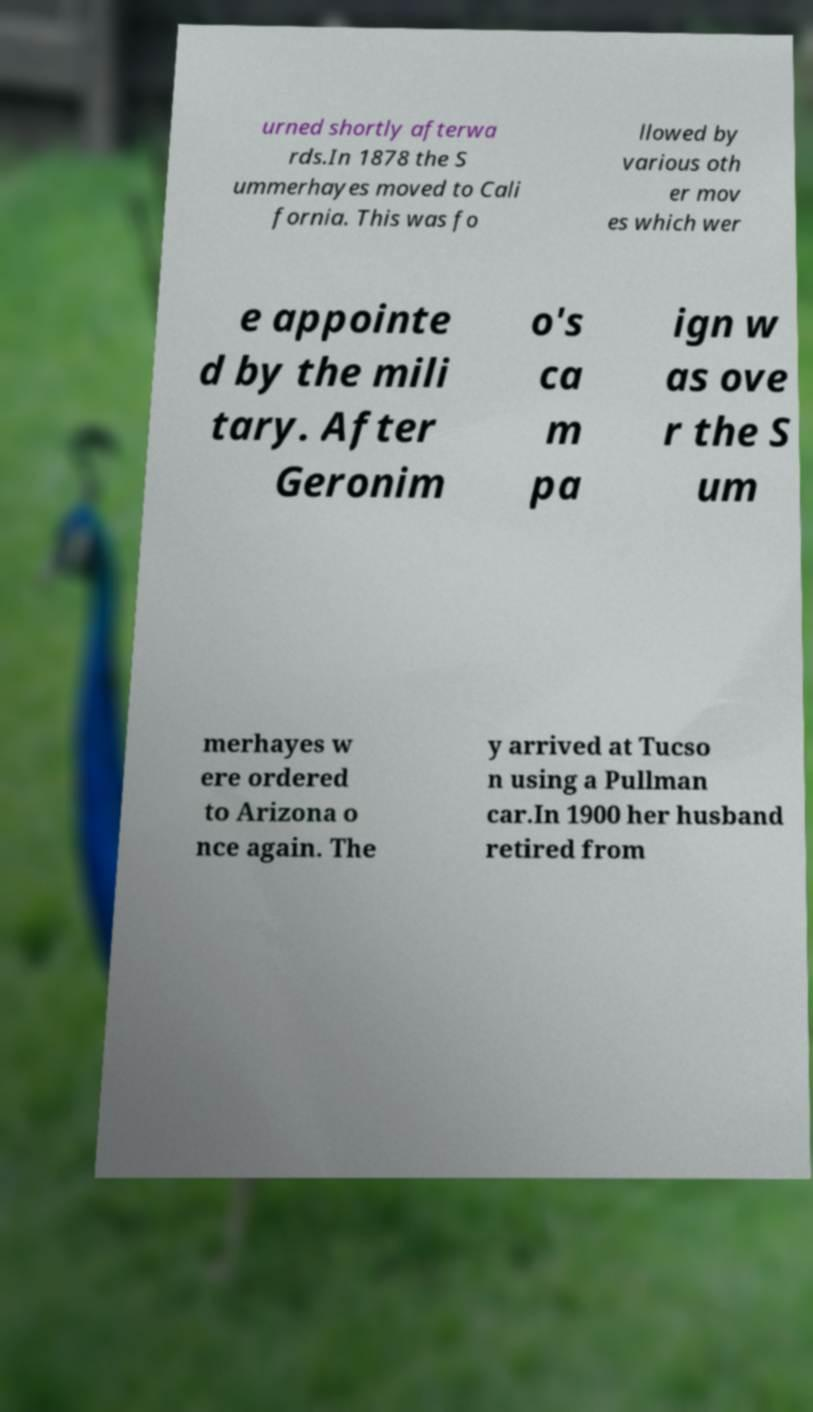Can you read and provide the text displayed in the image?This photo seems to have some interesting text. Can you extract and type it out for me? urned shortly afterwa rds.In 1878 the S ummerhayes moved to Cali fornia. This was fo llowed by various oth er mov es which wer e appointe d by the mili tary. After Geronim o's ca m pa ign w as ove r the S um merhayes w ere ordered to Arizona o nce again. The y arrived at Tucso n using a Pullman car.In 1900 her husband retired from 